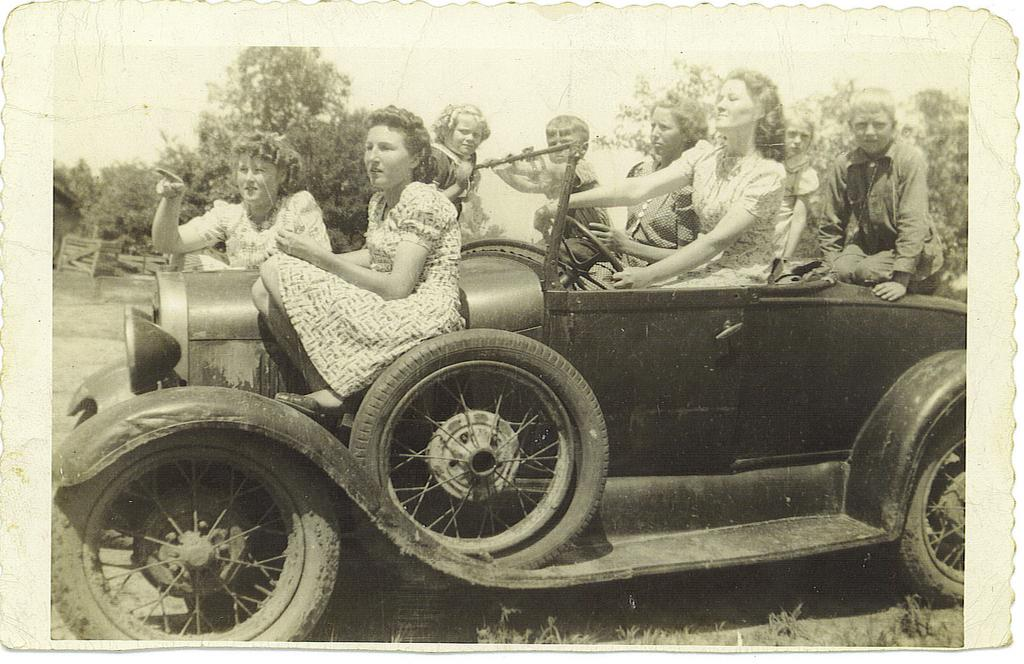What is the color scheme of the image? The image is black and white. What are the people in the image doing? The people are sitting on a car. How many wheels does the car have? The car has three wheels. What lighting features are present on the car? There are headlights on the car. What can be seen in the background of the image? Trees are visible in the background of the image. What type of mask is the person wearing while sitting on the car? There is no person wearing a mask in the image; the people are not wearing any masks. Can you tell me how much cheese is present in the image? There is no cheese present in the image; it is not a food-related image. 